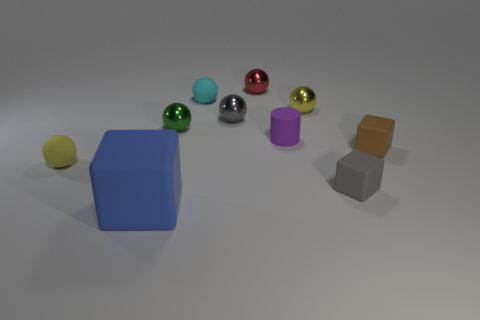There is a matte object that is behind the brown object and in front of the cyan sphere; how big is it?
Ensure brevity in your answer.  Small. There is a tiny purple rubber object; are there any big objects on the right side of it?
Keep it short and to the point. No. How many objects are either tiny matte objects that are in front of the tiny brown thing or tiny cylinders?
Keep it short and to the point. 3. How many objects are behind the small gray thing that is in front of the gray metallic sphere?
Provide a short and direct response. 8. Is the number of tiny things on the right side of the small gray shiny ball less than the number of large objects that are right of the brown rubber object?
Your response must be concise. No. What shape is the purple thing that is in front of the tiny yellow sphere that is behind the gray metal object?
Keep it short and to the point. Cylinder. What number of other objects are the same material as the large blue block?
Keep it short and to the point. 5. Are there any other things that have the same size as the gray sphere?
Make the answer very short. Yes. Is the number of cyan rubber spheres greater than the number of big red matte cylinders?
Ensure brevity in your answer.  Yes. How big is the cube left of the gray object in front of the metallic object that is left of the gray metal object?
Provide a short and direct response. Large. 